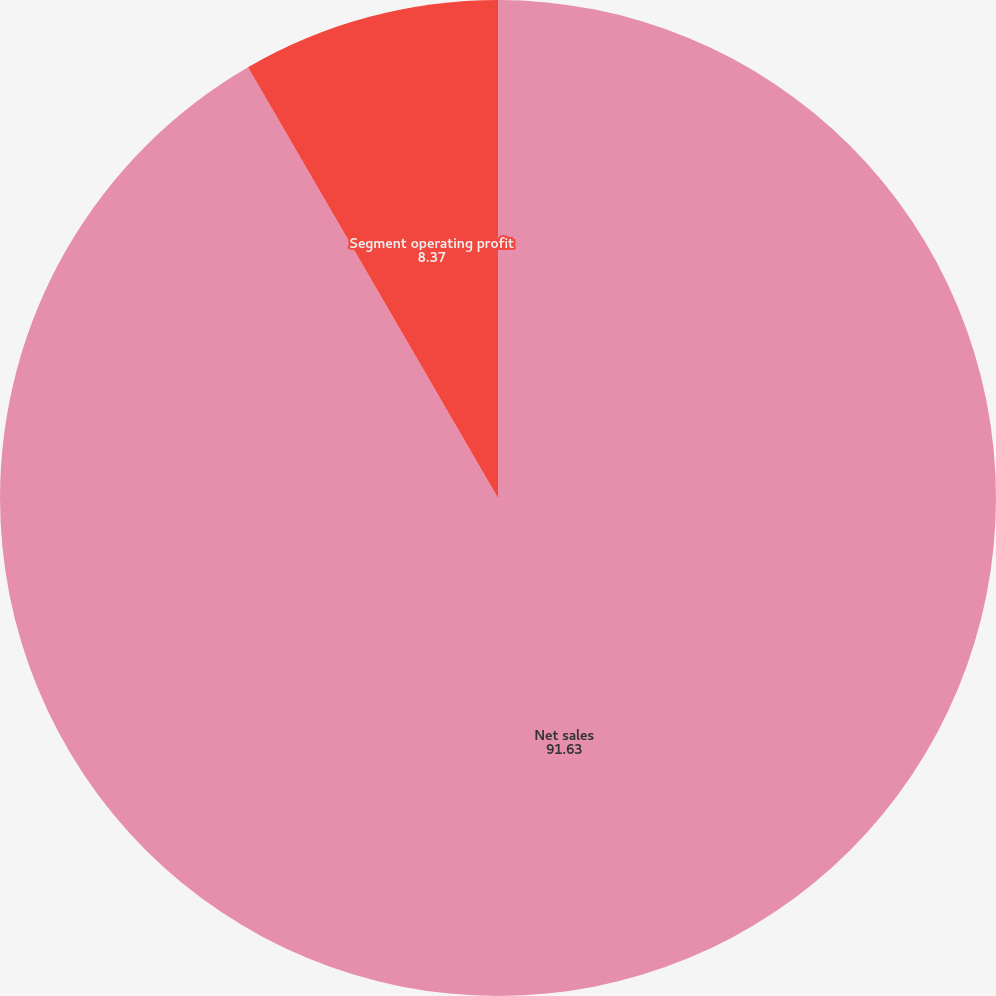Convert chart to OTSL. <chart><loc_0><loc_0><loc_500><loc_500><pie_chart><fcel>Net sales<fcel>Segment operating profit<nl><fcel>91.63%<fcel>8.37%<nl></chart> 